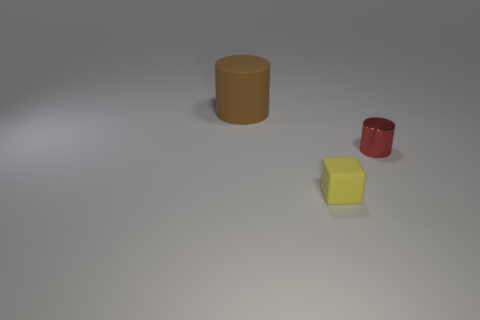Is there any other thing that is the same size as the brown rubber thing?
Offer a terse response. No. What number of matte balls are there?
Offer a very short reply. 0. How many large cylinders have the same material as the yellow object?
Offer a very short reply. 1. What size is the brown rubber object that is the same shape as the red thing?
Make the answer very short. Large. What is the material of the large brown cylinder?
Offer a very short reply. Rubber. The cylinder that is in front of the thing that is left of the matte thing that is in front of the small shiny object is made of what material?
Provide a succinct answer. Metal. Are there any other things that have the same shape as the small matte thing?
Keep it short and to the point. No. There is a tiny thing that is the same shape as the big matte thing; what color is it?
Make the answer very short. Red. Are there more matte objects behind the tiny yellow thing than big cyan rubber cylinders?
Provide a succinct answer. Yes. What number of other things are the same size as the block?
Give a very brief answer. 1. 